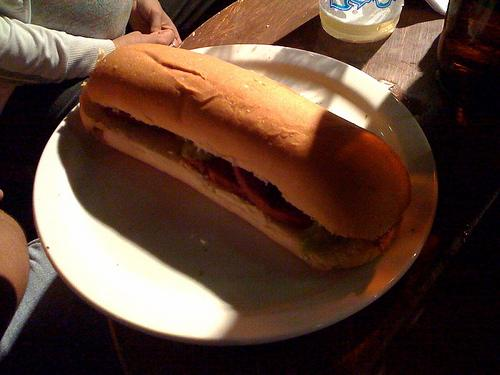What is the focus of this image in terms of objects and actions? The focus of the image is on a sandwich on a plate, with no specific action taking place. Describe the types of items displayed on the table in the image. There is a sandwich on a plate displayed on the table. Based on the objects in the image, what kind of social event might be going on? Based on the object in the image, it could be a casual dining setting. Identify and describe the human body parts that are present in the image. In the image, there is a partial view of a person's left arm. Identify any food items that are visible inside the sandwiches. The sandwich contains some type of meat, possibly salami, and there appears to be lettuce as well. Is there any visible food interaction or preparation taking place in the image? No, there is no visible food interaction or preparation taking place in the image. Create a short story based on the image you've just seen. Late one evening, Sarah decided to treat herself to a delicious sandwich at her favorite local pub. She ordered a sandwich filled with salami and lettuce, which was served on a soft, fresh bun. As she sat at the wooden table, the dim light created a cozy atmosphere, perfect for enjoying her meal quietly. This simple pleasure was a delightful break in her busy week. Count the number of buns on plates visible in the image. There is one bun on a plate visible in the image. 